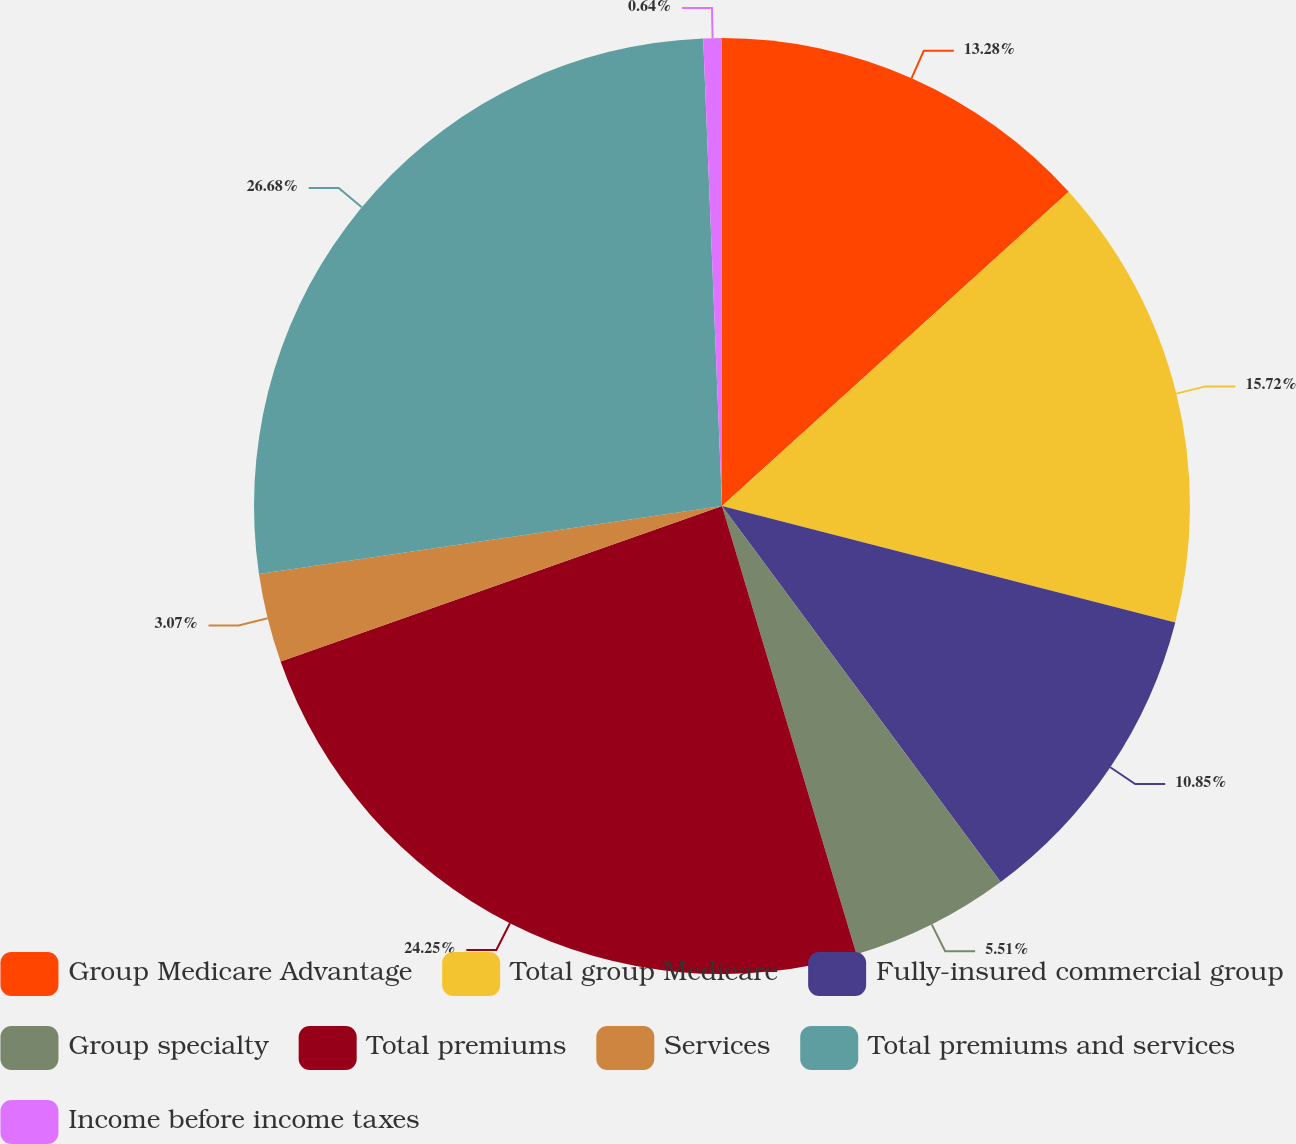<chart> <loc_0><loc_0><loc_500><loc_500><pie_chart><fcel>Group Medicare Advantage<fcel>Total group Medicare<fcel>Fully-insured commercial group<fcel>Group specialty<fcel>Total premiums<fcel>Services<fcel>Total premiums and services<fcel>Income before income taxes<nl><fcel>13.28%<fcel>15.72%<fcel>10.85%<fcel>5.51%<fcel>24.25%<fcel>3.07%<fcel>26.68%<fcel>0.64%<nl></chart> 